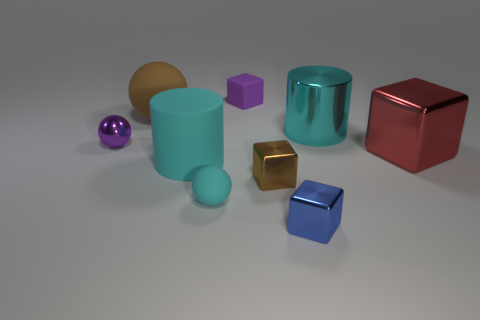There is a brown thing that is behind the cylinder that is left of the small blue thing; what number of purple matte things are in front of it?
Make the answer very short. 0. There is another large thing that is the same shape as the cyan shiny object; what material is it?
Your answer should be very brief. Rubber. What is the thing that is both on the right side of the blue cube and in front of the metallic cylinder made of?
Provide a succinct answer. Metal. Is the number of small shiny cubes that are left of the small purple metallic object less than the number of brown shiny blocks right of the small brown cube?
Give a very brief answer. No. What number of other things are there of the same size as the metal cylinder?
Your answer should be compact. 3. There is a small matte thing that is right of the cyan rubber ball that is left of the big cylinder that is behind the red thing; what shape is it?
Offer a terse response. Cube. What number of yellow things are either spheres or small shiny spheres?
Offer a terse response. 0. How many purple things are behind the purple object to the left of the tiny rubber cube?
Your answer should be very brief. 1. Is there anything else that has the same color as the big metallic cube?
Your response must be concise. No. There is a big thing that is the same material as the big ball; what shape is it?
Provide a succinct answer. Cylinder. 